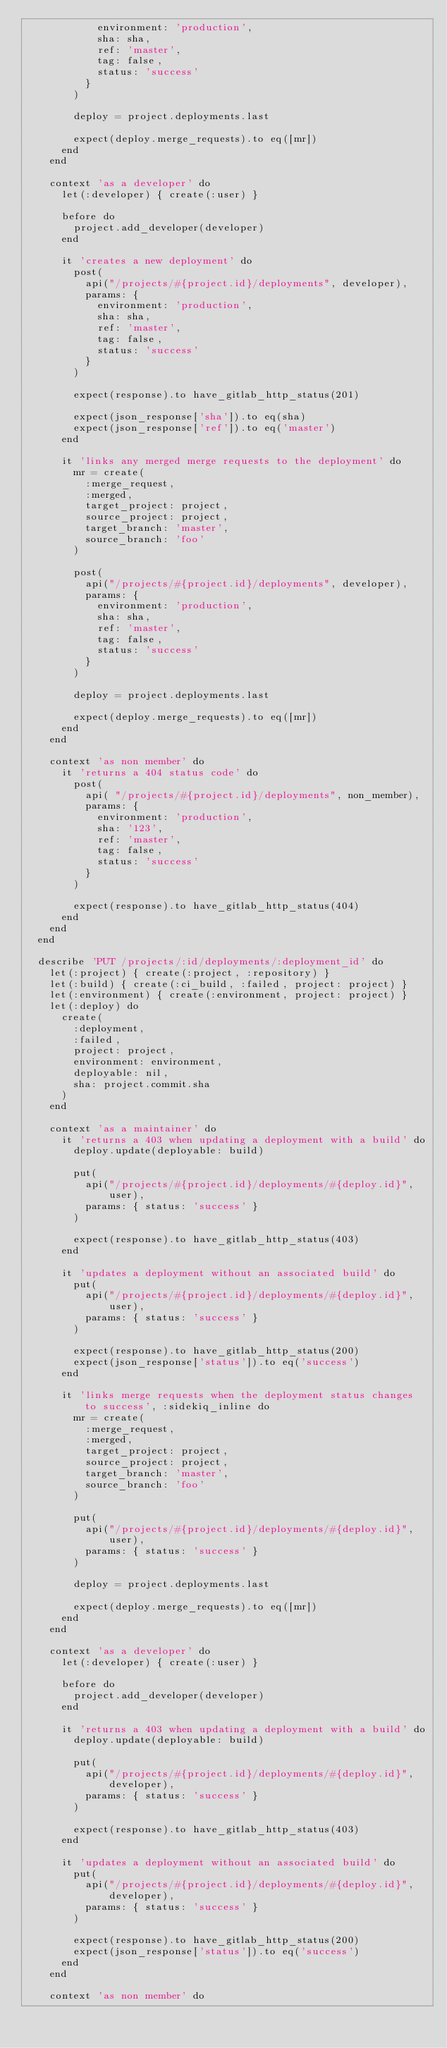<code> <loc_0><loc_0><loc_500><loc_500><_Ruby_>            environment: 'production',
            sha: sha,
            ref: 'master',
            tag: false,
            status: 'success'
          }
        )

        deploy = project.deployments.last

        expect(deploy.merge_requests).to eq([mr])
      end
    end

    context 'as a developer' do
      let(:developer) { create(:user) }

      before do
        project.add_developer(developer)
      end

      it 'creates a new deployment' do
        post(
          api("/projects/#{project.id}/deployments", developer),
          params: {
            environment: 'production',
            sha: sha,
            ref: 'master',
            tag: false,
            status: 'success'
          }
        )

        expect(response).to have_gitlab_http_status(201)

        expect(json_response['sha']).to eq(sha)
        expect(json_response['ref']).to eq('master')
      end

      it 'links any merged merge requests to the deployment' do
        mr = create(
          :merge_request,
          :merged,
          target_project: project,
          source_project: project,
          target_branch: 'master',
          source_branch: 'foo'
        )

        post(
          api("/projects/#{project.id}/deployments", developer),
          params: {
            environment: 'production',
            sha: sha,
            ref: 'master',
            tag: false,
            status: 'success'
          }
        )

        deploy = project.deployments.last

        expect(deploy.merge_requests).to eq([mr])
      end
    end

    context 'as non member' do
      it 'returns a 404 status code' do
        post(
          api( "/projects/#{project.id}/deployments", non_member),
          params: {
            environment: 'production',
            sha: '123',
            ref: 'master',
            tag: false,
            status: 'success'
          }
        )

        expect(response).to have_gitlab_http_status(404)
      end
    end
  end

  describe 'PUT /projects/:id/deployments/:deployment_id' do
    let(:project) { create(:project, :repository) }
    let(:build) { create(:ci_build, :failed, project: project) }
    let(:environment) { create(:environment, project: project) }
    let(:deploy) do
      create(
        :deployment,
        :failed,
        project: project,
        environment: environment,
        deployable: nil,
        sha: project.commit.sha
      )
    end

    context 'as a maintainer' do
      it 'returns a 403 when updating a deployment with a build' do
        deploy.update(deployable: build)

        put(
          api("/projects/#{project.id}/deployments/#{deploy.id}", user),
          params: { status: 'success' }
        )

        expect(response).to have_gitlab_http_status(403)
      end

      it 'updates a deployment without an associated build' do
        put(
          api("/projects/#{project.id}/deployments/#{deploy.id}", user),
          params: { status: 'success' }
        )

        expect(response).to have_gitlab_http_status(200)
        expect(json_response['status']).to eq('success')
      end

      it 'links merge requests when the deployment status changes to success', :sidekiq_inline do
        mr = create(
          :merge_request,
          :merged,
          target_project: project,
          source_project: project,
          target_branch: 'master',
          source_branch: 'foo'
        )

        put(
          api("/projects/#{project.id}/deployments/#{deploy.id}", user),
          params: { status: 'success' }
        )

        deploy = project.deployments.last

        expect(deploy.merge_requests).to eq([mr])
      end
    end

    context 'as a developer' do
      let(:developer) { create(:user) }

      before do
        project.add_developer(developer)
      end

      it 'returns a 403 when updating a deployment with a build' do
        deploy.update(deployable: build)

        put(
          api("/projects/#{project.id}/deployments/#{deploy.id}", developer),
          params: { status: 'success' }
        )

        expect(response).to have_gitlab_http_status(403)
      end

      it 'updates a deployment without an associated build' do
        put(
          api("/projects/#{project.id}/deployments/#{deploy.id}", developer),
          params: { status: 'success' }
        )

        expect(response).to have_gitlab_http_status(200)
        expect(json_response['status']).to eq('success')
      end
    end

    context 'as non member' do</code> 